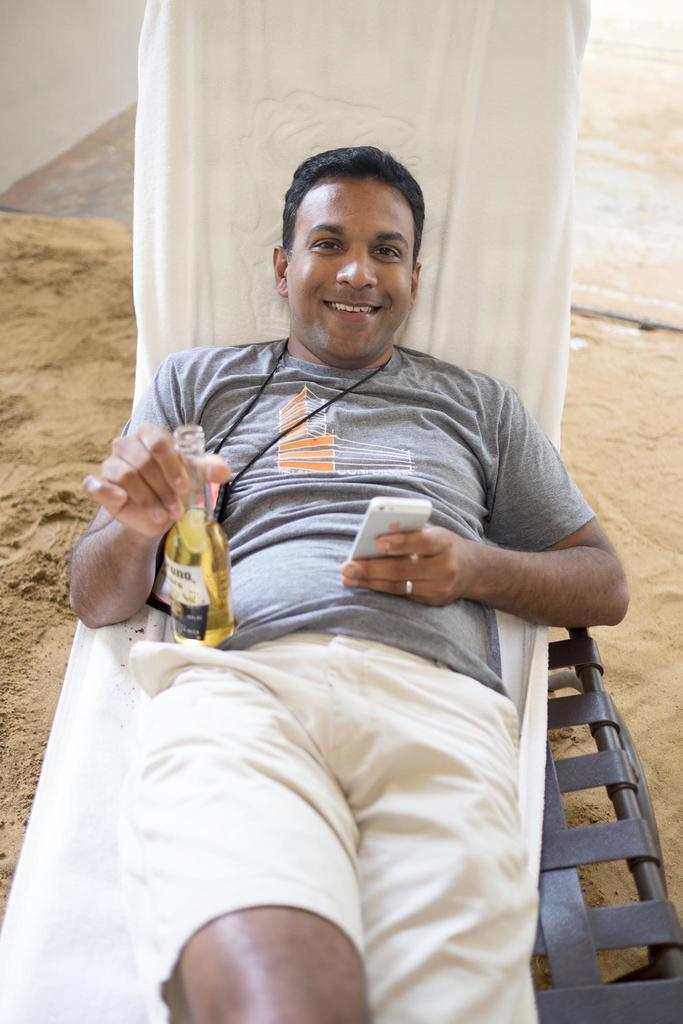Who is the main subject in the image? There is a man in the image. What is the man holding in his hand? The man is holding a bottle and a mobile phone. What is the man's position in the image? The man is laying on a bed. What type of cherry is the man eating in the image? There is no cherry present in the image. Who is the owner of the mobile phone the man is holding? The image does not provide information about the ownership of the mobile phone. 